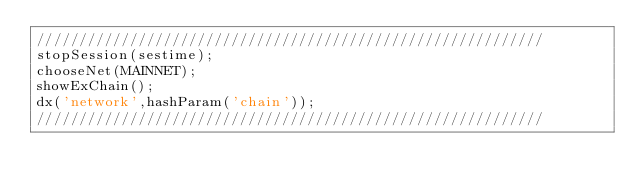Convert code to text. <code><loc_0><loc_0><loc_500><loc_500><_JavaScript_>////////////////////////////////////////////////////////////
stopSession(sestime);
chooseNet(MAINNET);
showExChain();
dx('network',hashParam('chain'));
////////////////////////////////////////////////////////////</code> 